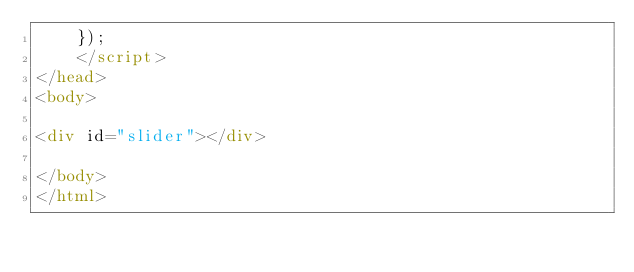<code> <loc_0><loc_0><loc_500><loc_500><_HTML_>	});
	</script>
</head>
<body>

<div id="slider"></div>

</body>
</html>
</code> 